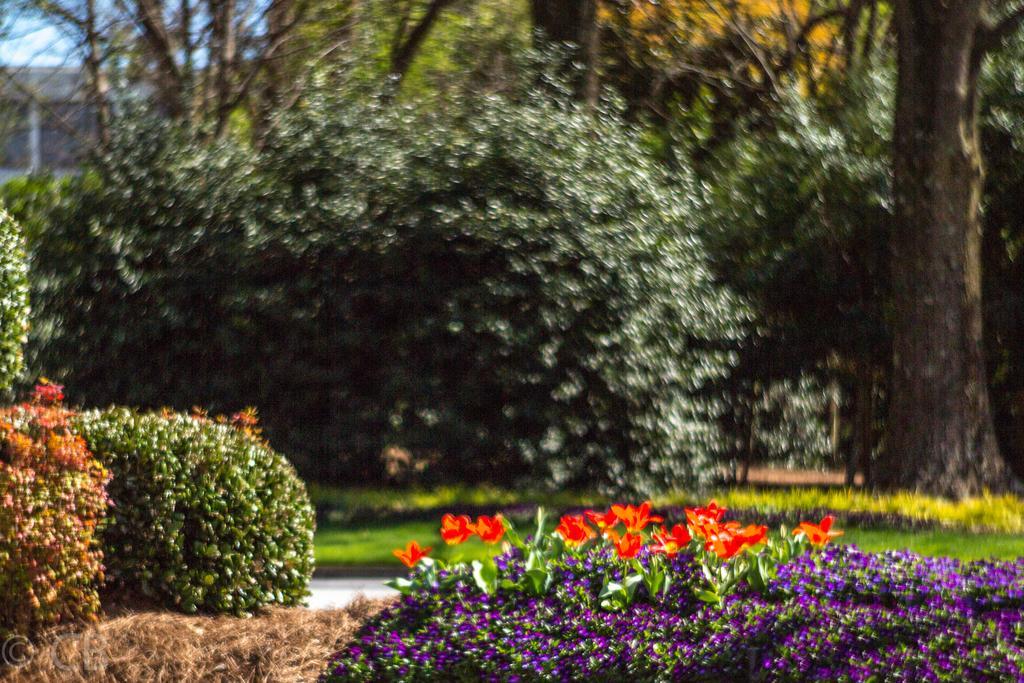In one or two sentences, can you explain what this image depicts? In this image, we can see flowers and plants. Background there is a blur view. here there are so many trees, building, grass and sky. 